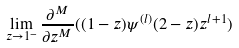<formula> <loc_0><loc_0><loc_500><loc_500>\lim _ { z \rightarrow 1 ^ { - } } \frac { \partial ^ { M } } { \partial z ^ { M } } ( ( 1 - z ) \psi ^ { ( l ) } ( 2 - z ) z ^ { l + 1 } )</formula> 